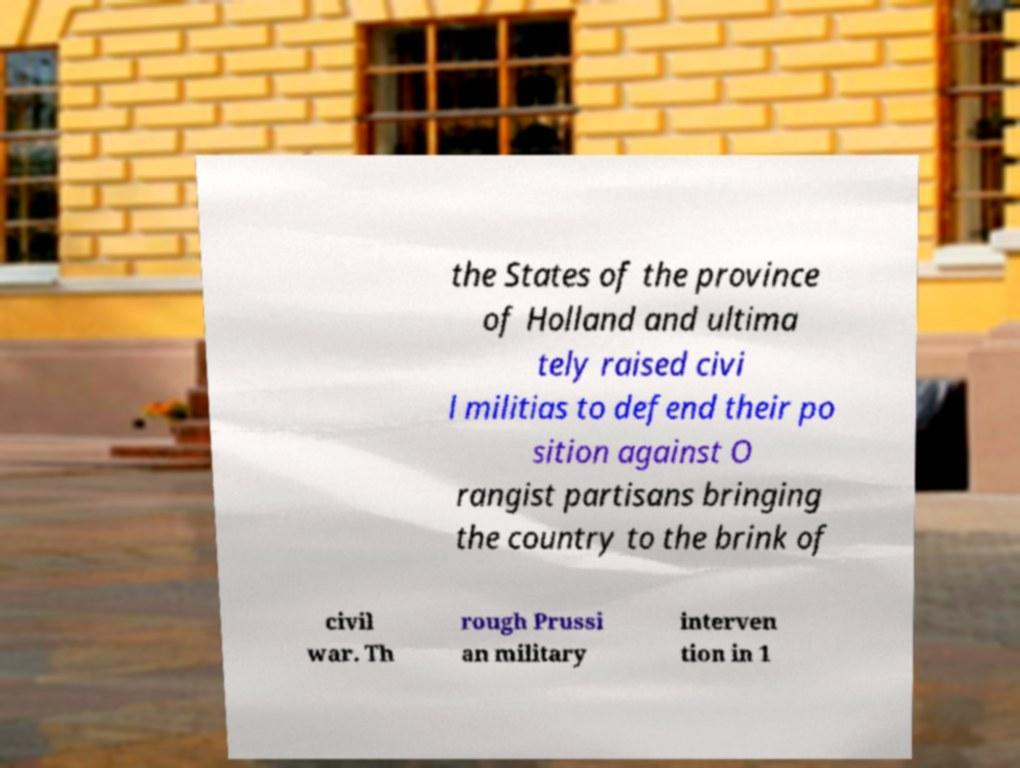Could you assist in decoding the text presented in this image and type it out clearly? the States of the province of Holland and ultima tely raised civi l militias to defend their po sition against O rangist partisans bringing the country to the brink of civil war. Th rough Prussi an military interven tion in 1 